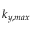Convert formula to latex. <formula><loc_0><loc_0><loc_500><loc_500>k _ { y , \max }</formula> 